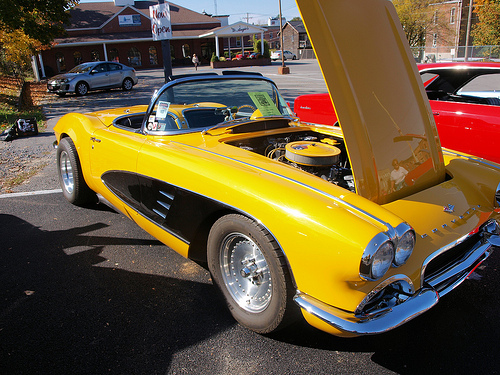<image>
Is there a tree on the asphalt? No. The tree is not positioned on the asphalt. They may be near each other, but the tree is not supported by or resting on top of the asphalt. Where is the car in relation to the hood? Is it behind the hood? Yes. From this viewpoint, the car is positioned behind the hood, with the hood partially or fully occluding the car. 